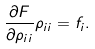Convert formula to latex. <formula><loc_0><loc_0><loc_500><loc_500>\frac { \partial F } { \partial \rho _ { i i } } \rho _ { i i } = f _ { i } .</formula> 